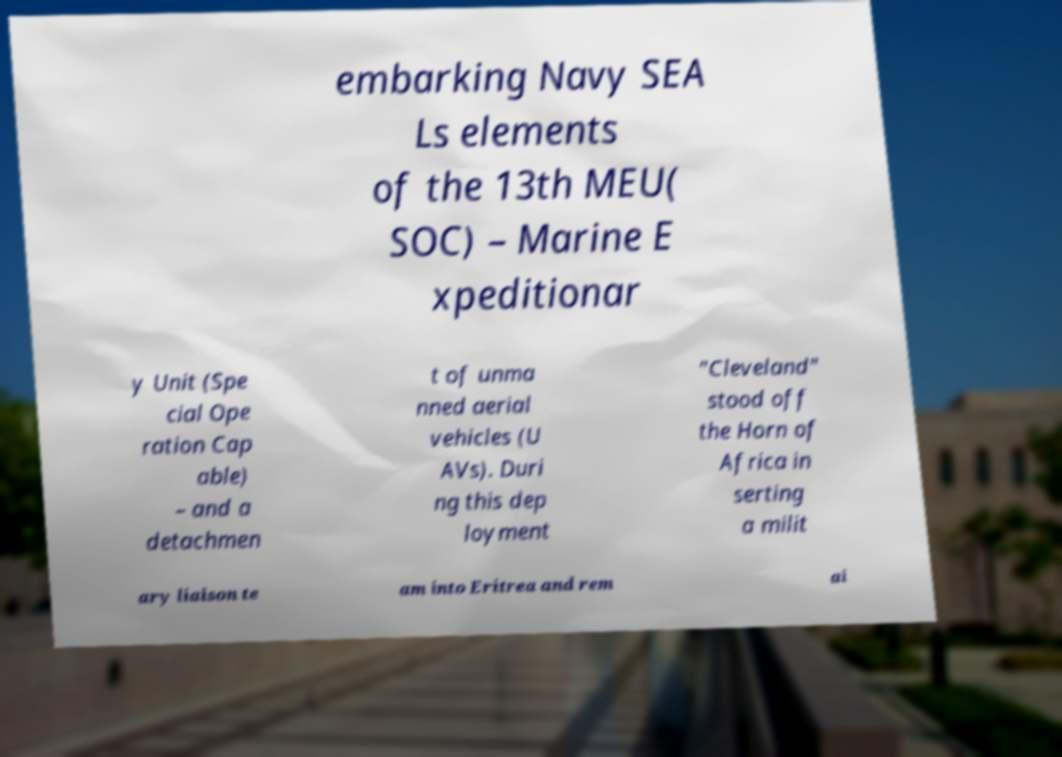Can you accurately transcribe the text from the provided image for me? embarking Navy SEA Ls elements of the 13th MEU( SOC) – Marine E xpeditionar y Unit (Spe cial Ope ration Cap able) – and a detachmen t of unma nned aerial vehicles (U AVs). Duri ng this dep loyment "Cleveland" stood off the Horn of Africa in serting a milit ary liaison te am into Eritrea and rem ai 